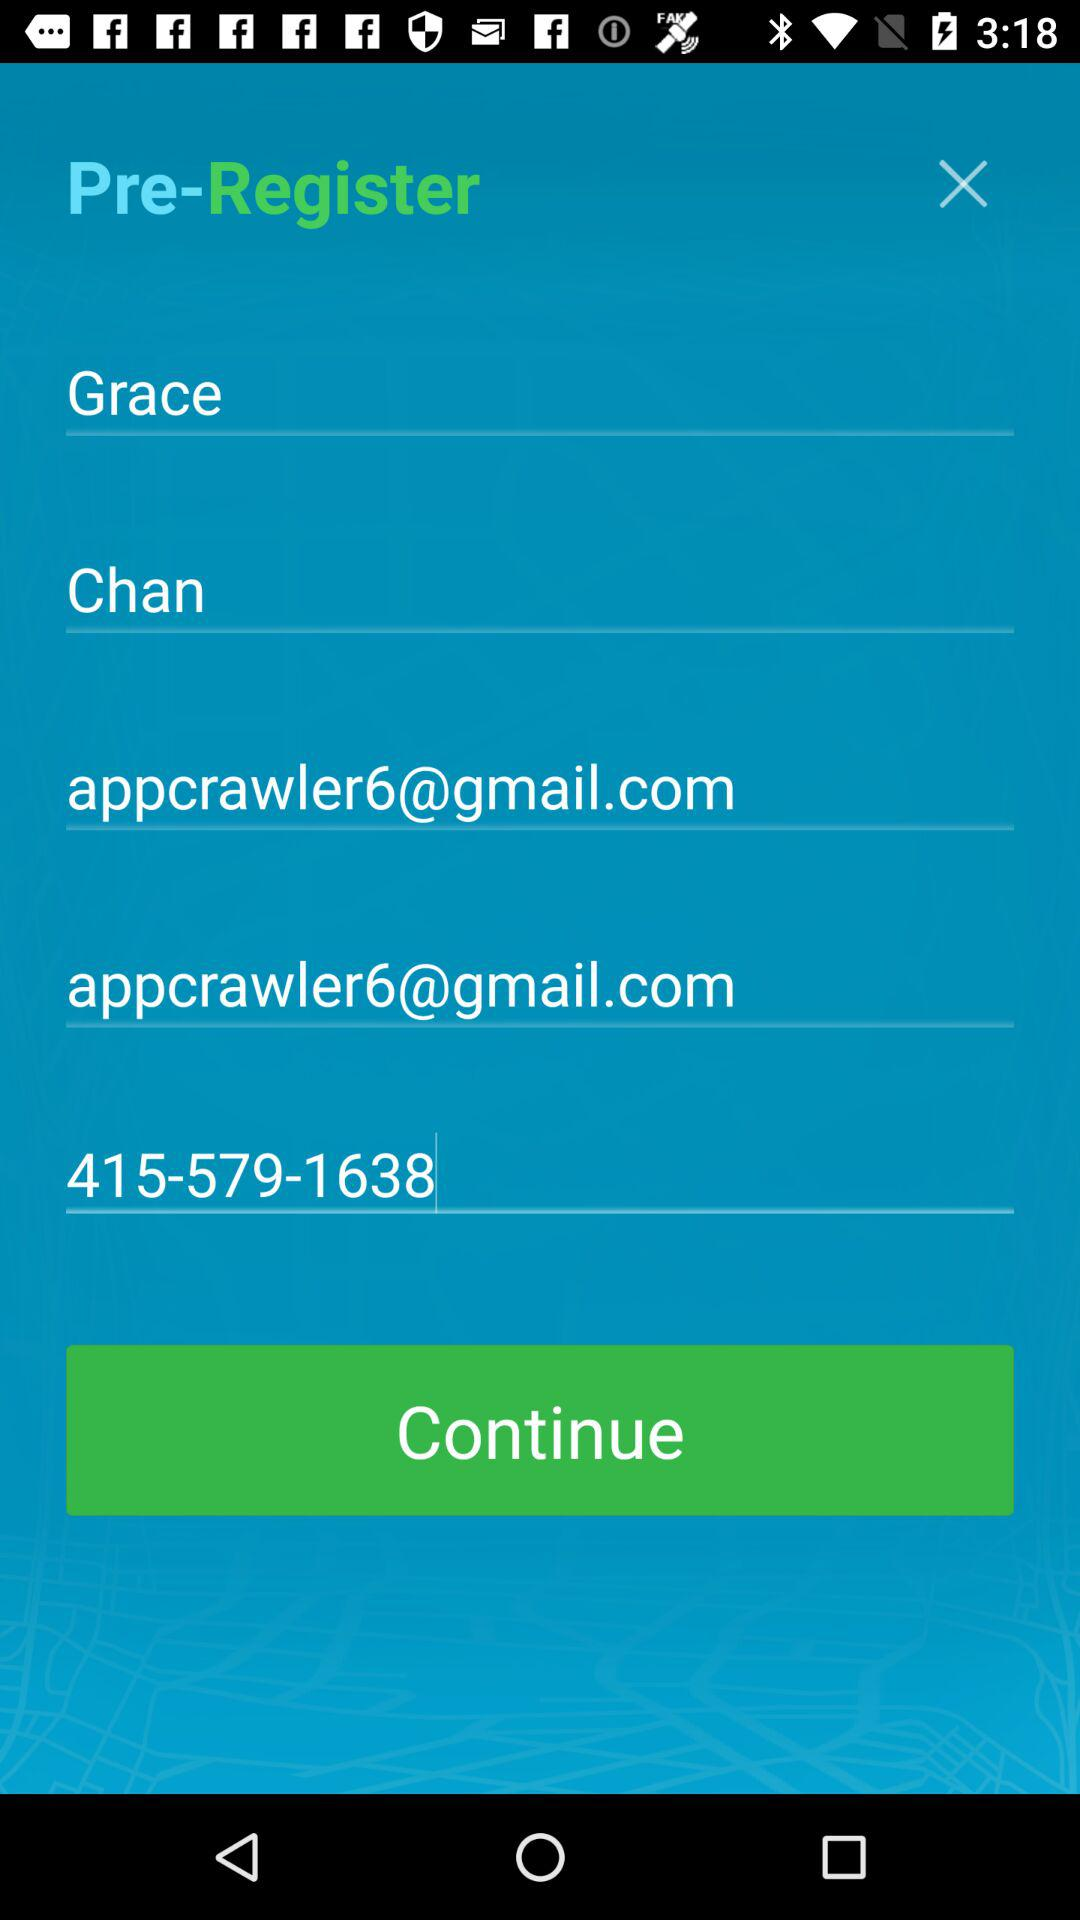What is the first name of the user? The first name of the user is Grace. 